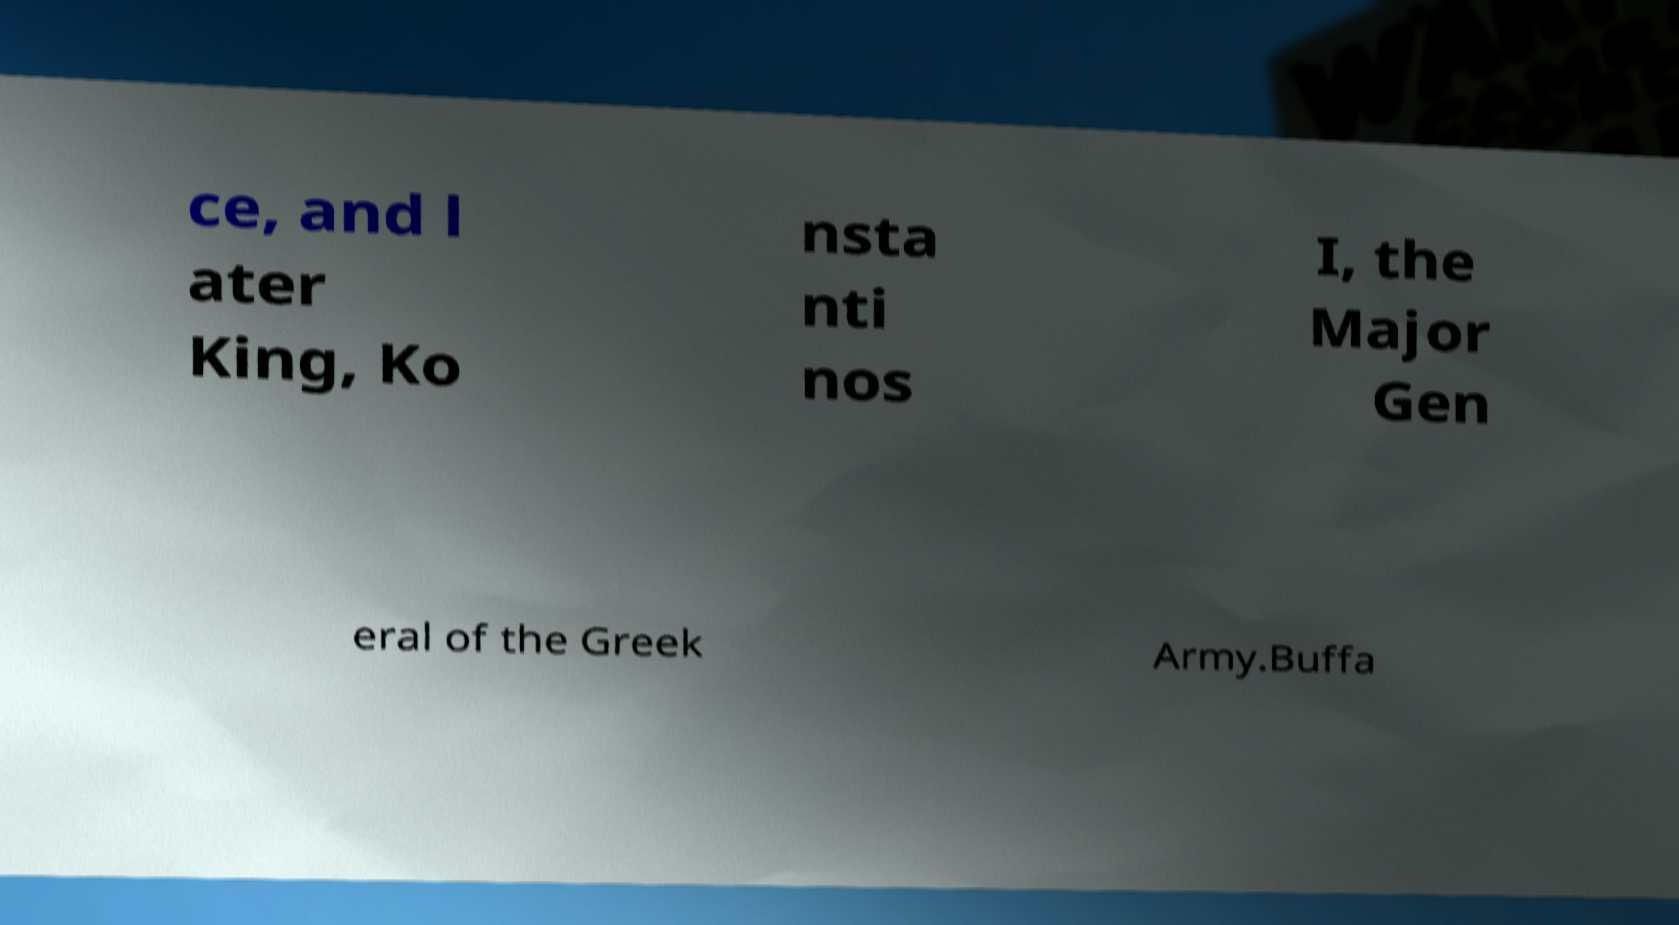There's text embedded in this image that I need extracted. Can you transcribe it verbatim? ce, and l ater King, Ko nsta nti nos I, the Major Gen eral of the Greek Army.Buffa 